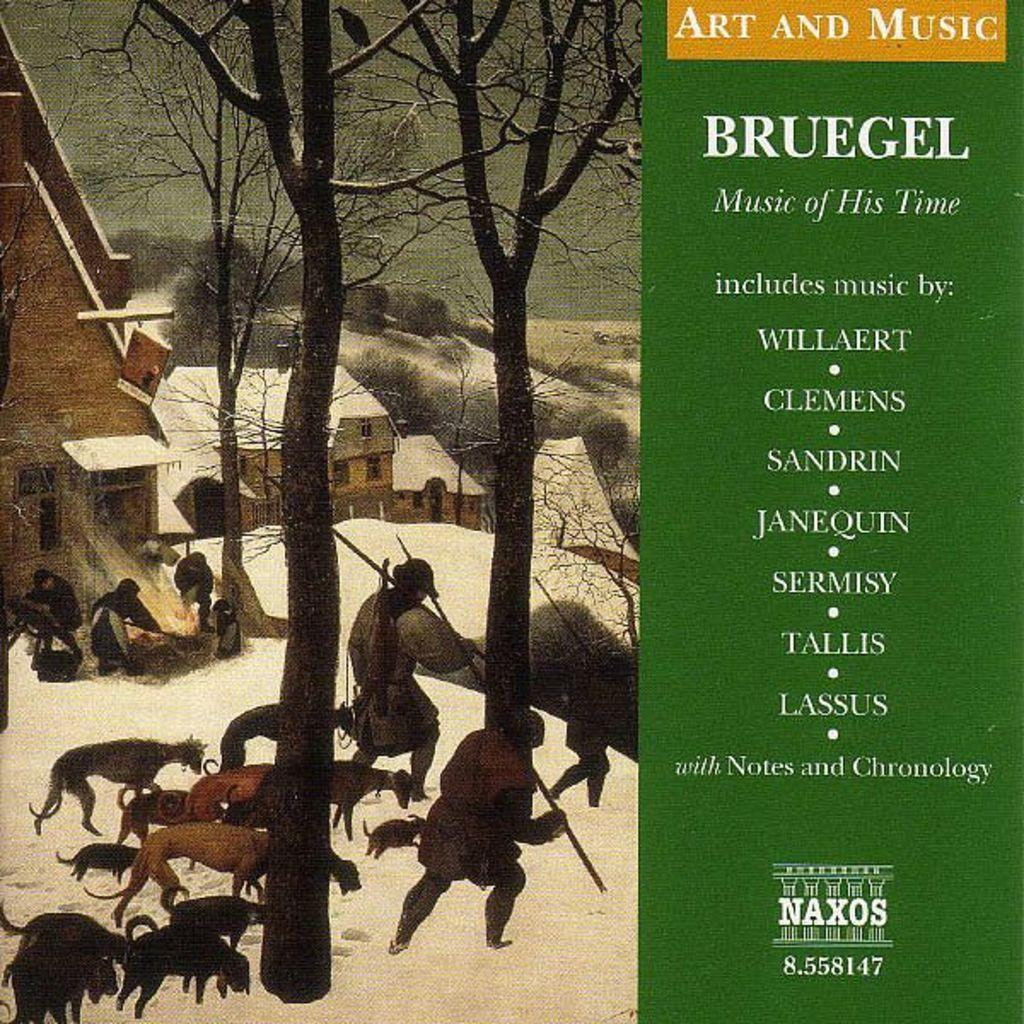What is the main subject of the poster in the image? The poster contains a painting of buildings. What other elements are included in the painting? The painting includes trees, animals, and a person on the snow. Are there any other features on the poster besides the painting? Yes, there is text on the poster. How many bats can be seen flying around the person in the painting? There are no bats present in the painting; it features buildings, trees, animals, and a person on the snow. What type of thrill can be experienced by the person depicted in the painting? The painting does not convey any specific emotions or experiences of the person; it simply shows a person on the snow. 